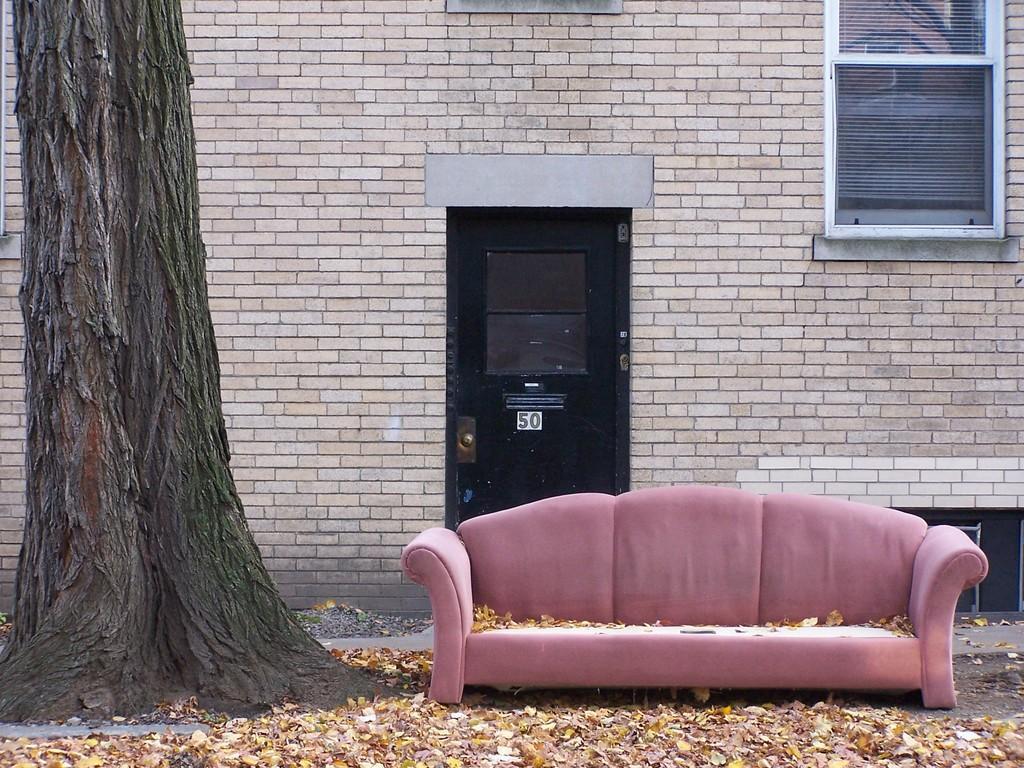Describe this image in one or two sentences. In this picture there is a sofa on the right side of the image and there is a trunk on the left side of the image, there is a door in the center of the image and there is a window in the top right side of the image. 